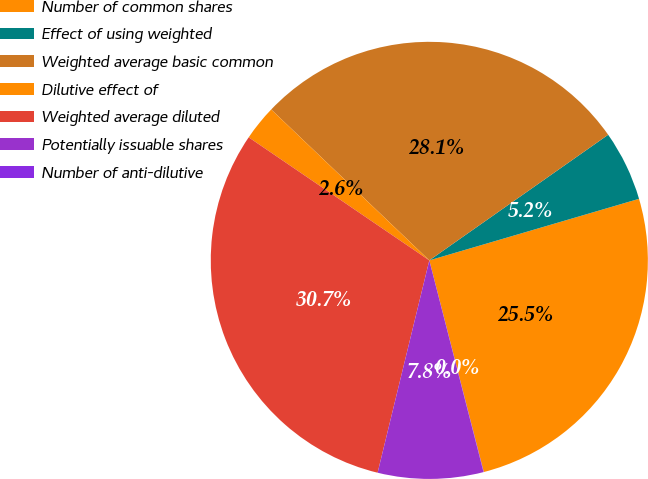<chart> <loc_0><loc_0><loc_500><loc_500><pie_chart><fcel>Number of common shares<fcel>Effect of using weighted<fcel>Weighted average basic common<fcel>Dilutive effect of<fcel>Weighted average diluted<fcel>Potentially issuable shares<fcel>Number of anti-dilutive<nl><fcel>25.53%<fcel>5.2%<fcel>28.12%<fcel>2.61%<fcel>30.71%<fcel>7.79%<fcel>0.02%<nl></chart> 